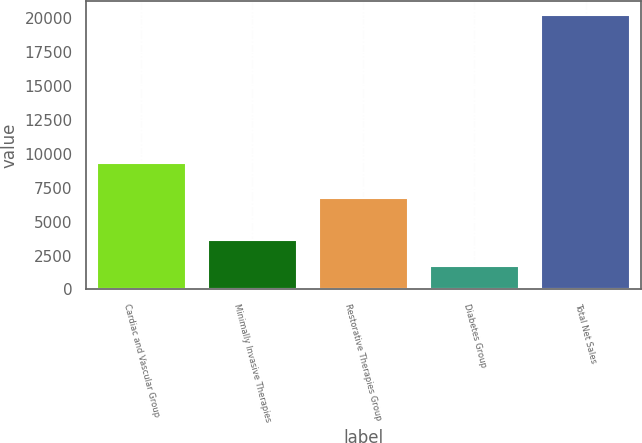<chart> <loc_0><loc_0><loc_500><loc_500><bar_chart><fcel>Cardiac and Vascular Group<fcel>Minimally Invasive Therapies<fcel>Restorative Therapies Group<fcel>Diabetes Group<fcel>Total Net Sales<nl><fcel>9361<fcel>3611.9<fcel>6751<fcel>1762<fcel>20261<nl></chart> 